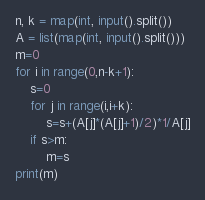<code> <loc_0><loc_0><loc_500><loc_500><_Python_>n, k = map(int, input().split())
A = list(map(int, input().split()))
m=0
for i in range(0,n-k+1):
    s=0
    for j in range(i,i+k):
        s=s+(A[j]*(A[j]+1)/2)*1/A[j]
    if s>m:
        m=s
print(m)</code> 